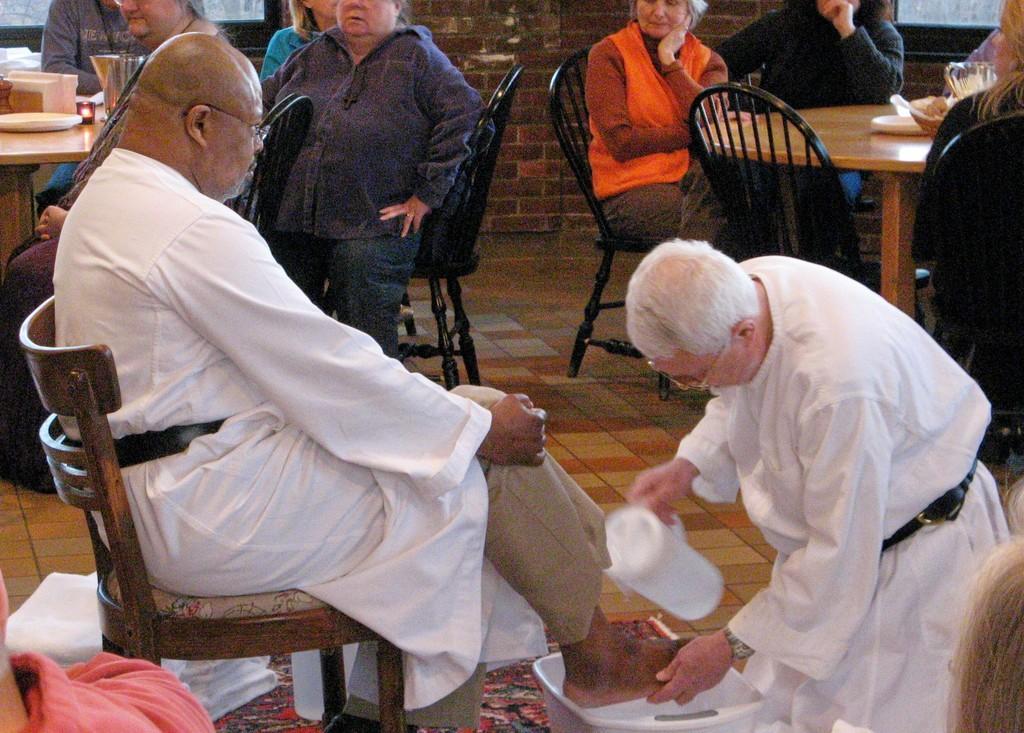How would you summarize this image in a sentence or two? This picture describes about group of people, they are seated on the chairs, on the right side of the image we can see a man, he is holding a jug, in front of him we ca see a tub, on top of the image we can see few things on the table. 